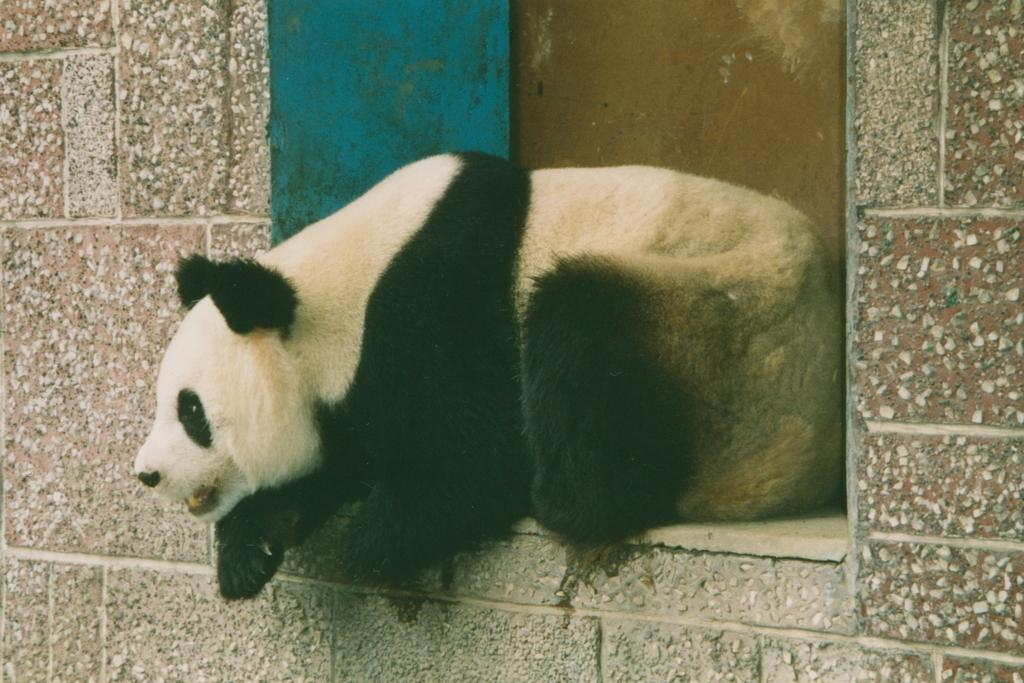What type of animal is in the image? The animal in the image has cream, black, and brown colors. Can you describe the background of the image? There is a wall in the background of the image. How many houses are visible in the image? There are no houses visible in the image; it only features an animal and a wall in the background. Can you tell me how many pears are on the ground in the image? There are no pears present in the image. 